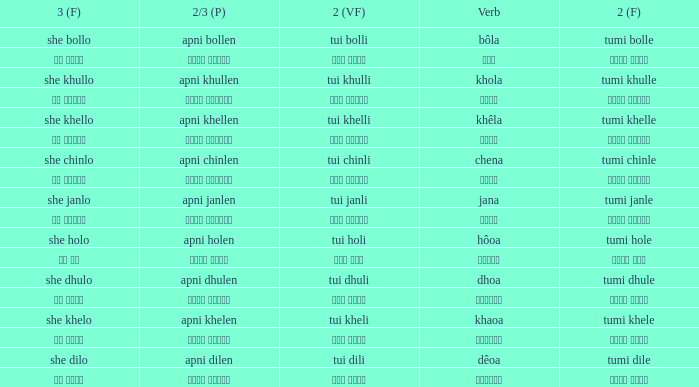What is the verb for Khola? She khullo. 